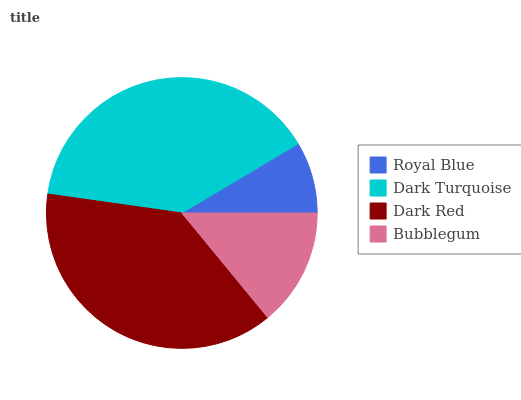Is Royal Blue the minimum?
Answer yes or no. Yes. Is Dark Turquoise the maximum?
Answer yes or no. Yes. Is Dark Red the minimum?
Answer yes or no. No. Is Dark Red the maximum?
Answer yes or no. No. Is Dark Turquoise greater than Dark Red?
Answer yes or no. Yes. Is Dark Red less than Dark Turquoise?
Answer yes or no. Yes. Is Dark Red greater than Dark Turquoise?
Answer yes or no. No. Is Dark Turquoise less than Dark Red?
Answer yes or no. No. Is Dark Red the high median?
Answer yes or no. Yes. Is Bubblegum the low median?
Answer yes or no. Yes. Is Dark Turquoise the high median?
Answer yes or no. No. Is Dark Turquoise the low median?
Answer yes or no. No. 